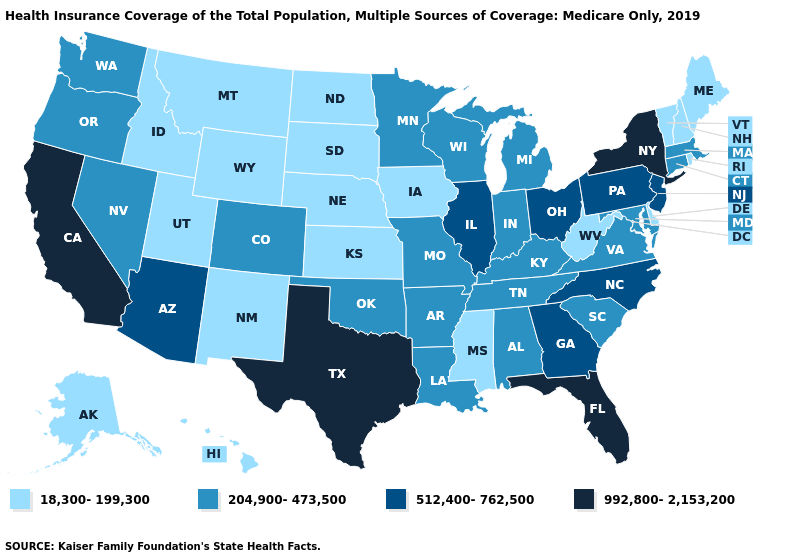Name the states that have a value in the range 512,400-762,500?
Be succinct. Arizona, Georgia, Illinois, New Jersey, North Carolina, Ohio, Pennsylvania. Name the states that have a value in the range 18,300-199,300?
Give a very brief answer. Alaska, Delaware, Hawaii, Idaho, Iowa, Kansas, Maine, Mississippi, Montana, Nebraska, New Hampshire, New Mexico, North Dakota, Rhode Island, South Dakota, Utah, Vermont, West Virginia, Wyoming. Does North Dakota have the same value as Mississippi?
Be succinct. Yes. Among the states that border Colorado , which have the lowest value?
Be succinct. Kansas, Nebraska, New Mexico, Utah, Wyoming. What is the value of New Mexico?
Be succinct. 18,300-199,300. Among the states that border Oregon , which have the highest value?
Write a very short answer. California. Does Utah have the lowest value in the USA?
Keep it brief. Yes. Does Arkansas have a higher value than Montana?
Be succinct. Yes. Name the states that have a value in the range 18,300-199,300?
Write a very short answer. Alaska, Delaware, Hawaii, Idaho, Iowa, Kansas, Maine, Mississippi, Montana, Nebraska, New Hampshire, New Mexico, North Dakota, Rhode Island, South Dakota, Utah, Vermont, West Virginia, Wyoming. Does the map have missing data?
Short answer required. No. What is the value of North Dakota?
Write a very short answer. 18,300-199,300. What is the value of Texas?
Keep it brief. 992,800-2,153,200. Does Mississippi have the highest value in the USA?
Concise answer only. No. 